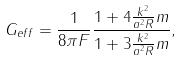<formula> <loc_0><loc_0><loc_500><loc_500>G _ { e f f } = { \frac { 1 } { 8 \pi F } } { \frac { 1 + 4 { \frac { k ^ { 2 } } { a ^ { 2 } R } } m } { 1 + 3 { \frac { k ^ { 2 } } { a ^ { 2 } R } } m } } ,</formula> 